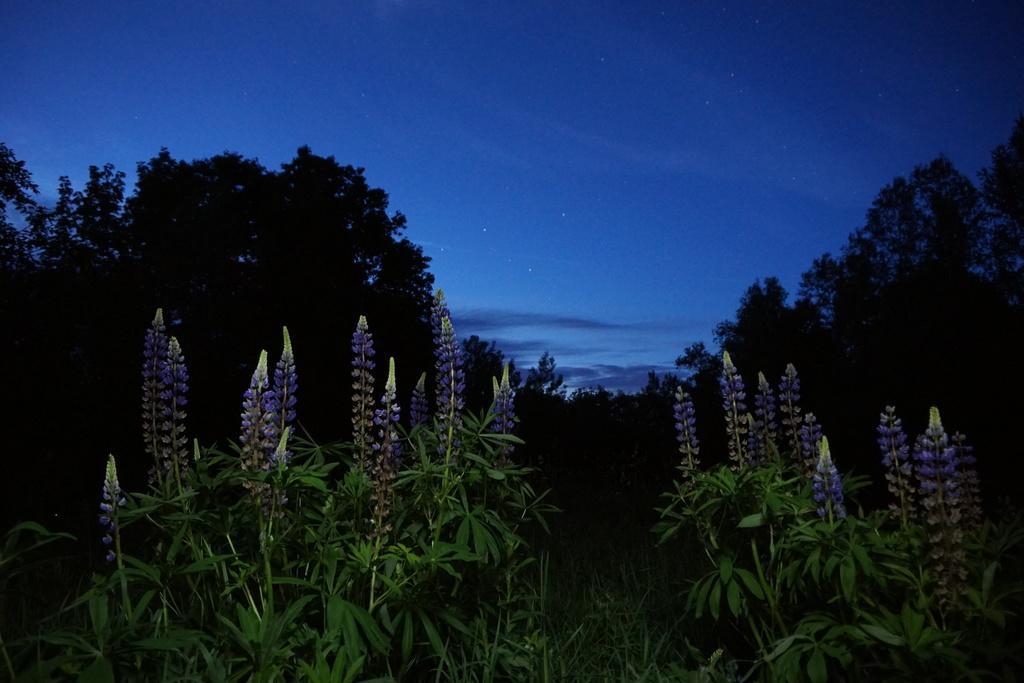Describe this image in one or two sentences. In this image I can see few plants in the front. In the background I can see number of trees, stars, clouds and the sky. 